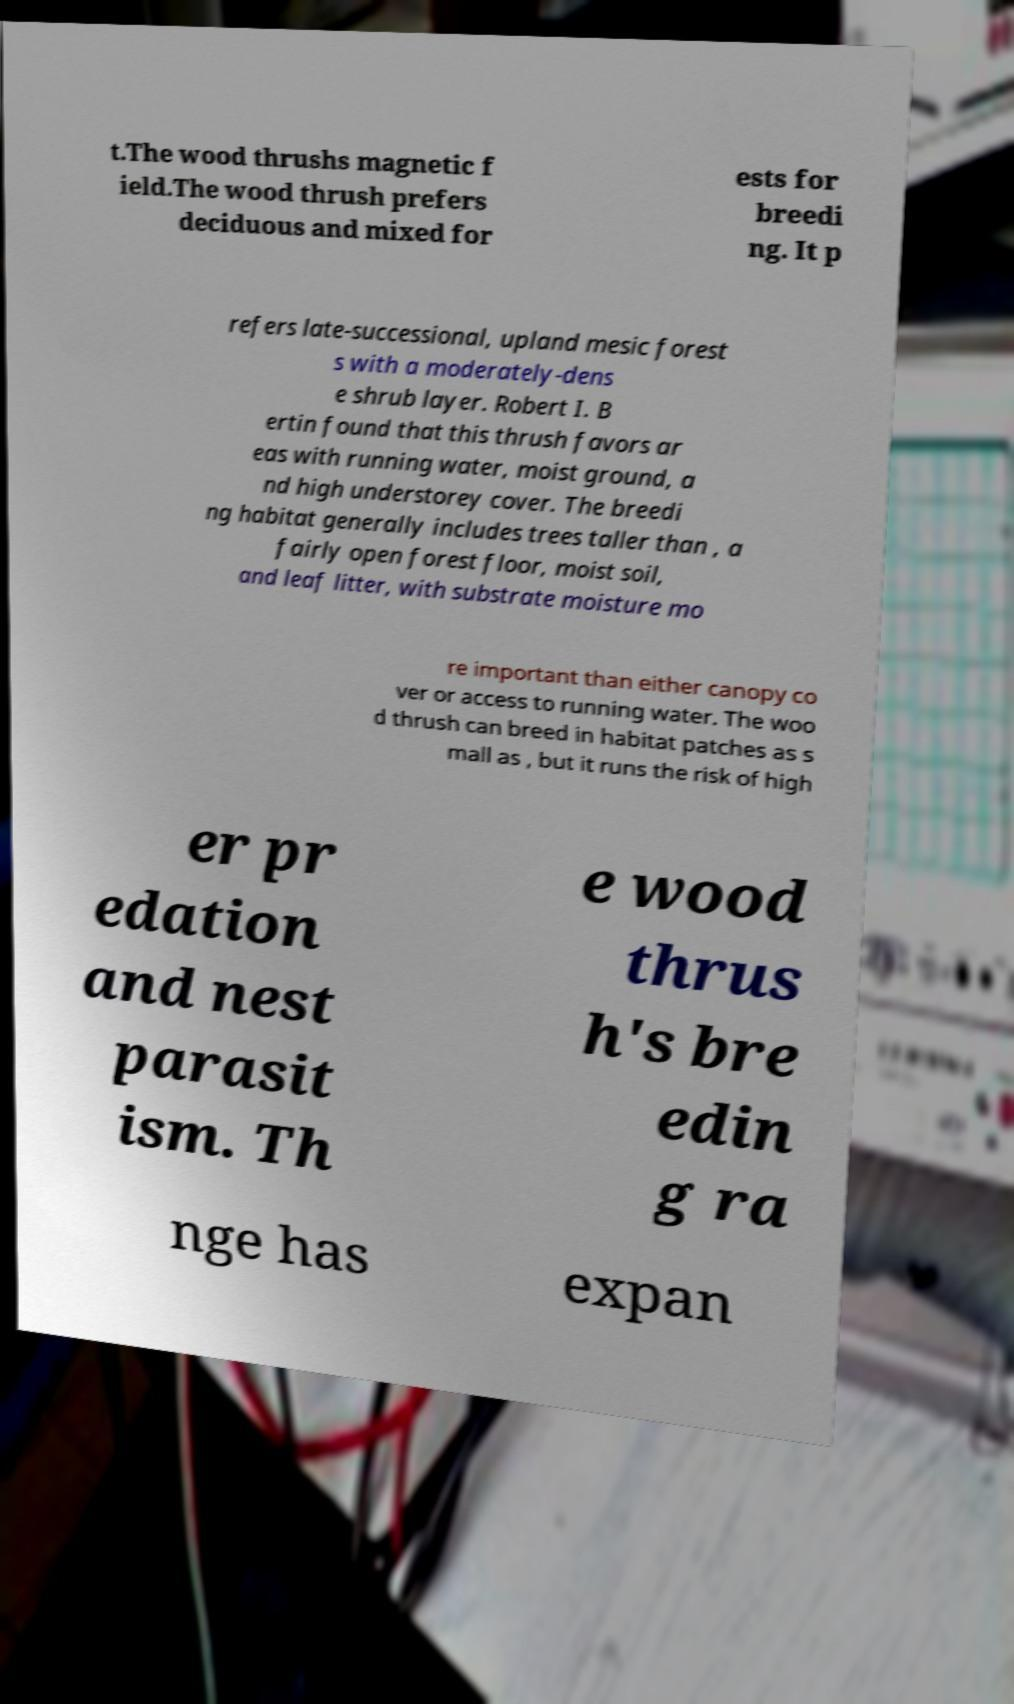What messages or text are displayed in this image? I need them in a readable, typed format. t.The wood thrushs magnetic f ield.The wood thrush prefers deciduous and mixed for ests for breedi ng. It p refers late-successional, upland mesic forest s with a moderately-dens e shrub layer. Robert I. B ertin found that this thrush favors ar eas with running water, moist ground, a nd high understorey cover. The breedi ng habitat generally includes trees taller than , a fairly open forest floor, moist soil, and leaf litter, with substrate moisture mo re important than either canopy co ver or access to running water. The woo d thrush can breed in habitat patches as s mall as , but it runs the risk of high er pr edation and nest parasit ism. Th e wood thrus h's bre edin g ra nge has expan 